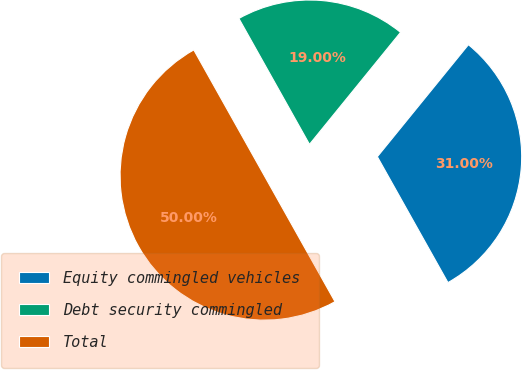Convert chart to OTSL. <chart><loc_0><loc_0><loc_500><loc_500><pie_chart><fcel>Equity commingled vehicles<fcel>Debt security commingled<fcel>Total<nl><fcel>31.0%<fcel>19.0%<fcel>50.0%<nl></chart> 